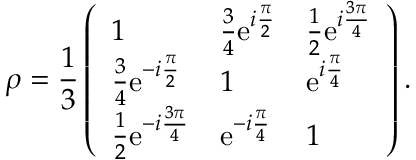Convert formula to latex. <formula><loc_0><loc_0><loc_500><loc_500>\rho = \frac { 1 } { 3 } \left ( \begin{array} { l l l } { 1 } & { \frac { 3 } { 4 } e ^ { i \frac { \pi } { 2 } } } & { \frac { 1 } { 2 } e ^ { i \frac { 3 \pi } { 4 } } } \\ { \frac { 3 } { 4 } e ^ { - i \frac { \pi } { 2 } } } & { 1 } & { e ^ { i \frac { \pi } { 4 } } } \\ { \frac { 1 } { 2 } e ^ { - i \frac { 3 \pi } { 4 } } } & { e ^ { - i \frac { \pi } { 4 } } } & { 1 } \end{array} \right ) .</formula> 